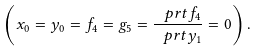<formula> <loc_0><loc_0><loc_500><loc_500>\left ( x _ { 0 } = y _ { 0 } = f _ { 4 } = g _ { 5 } = \frac { \ p r t f _ { 4 } } { \ p r t y _ { 1 } } = 0 \right ) .</formula> 